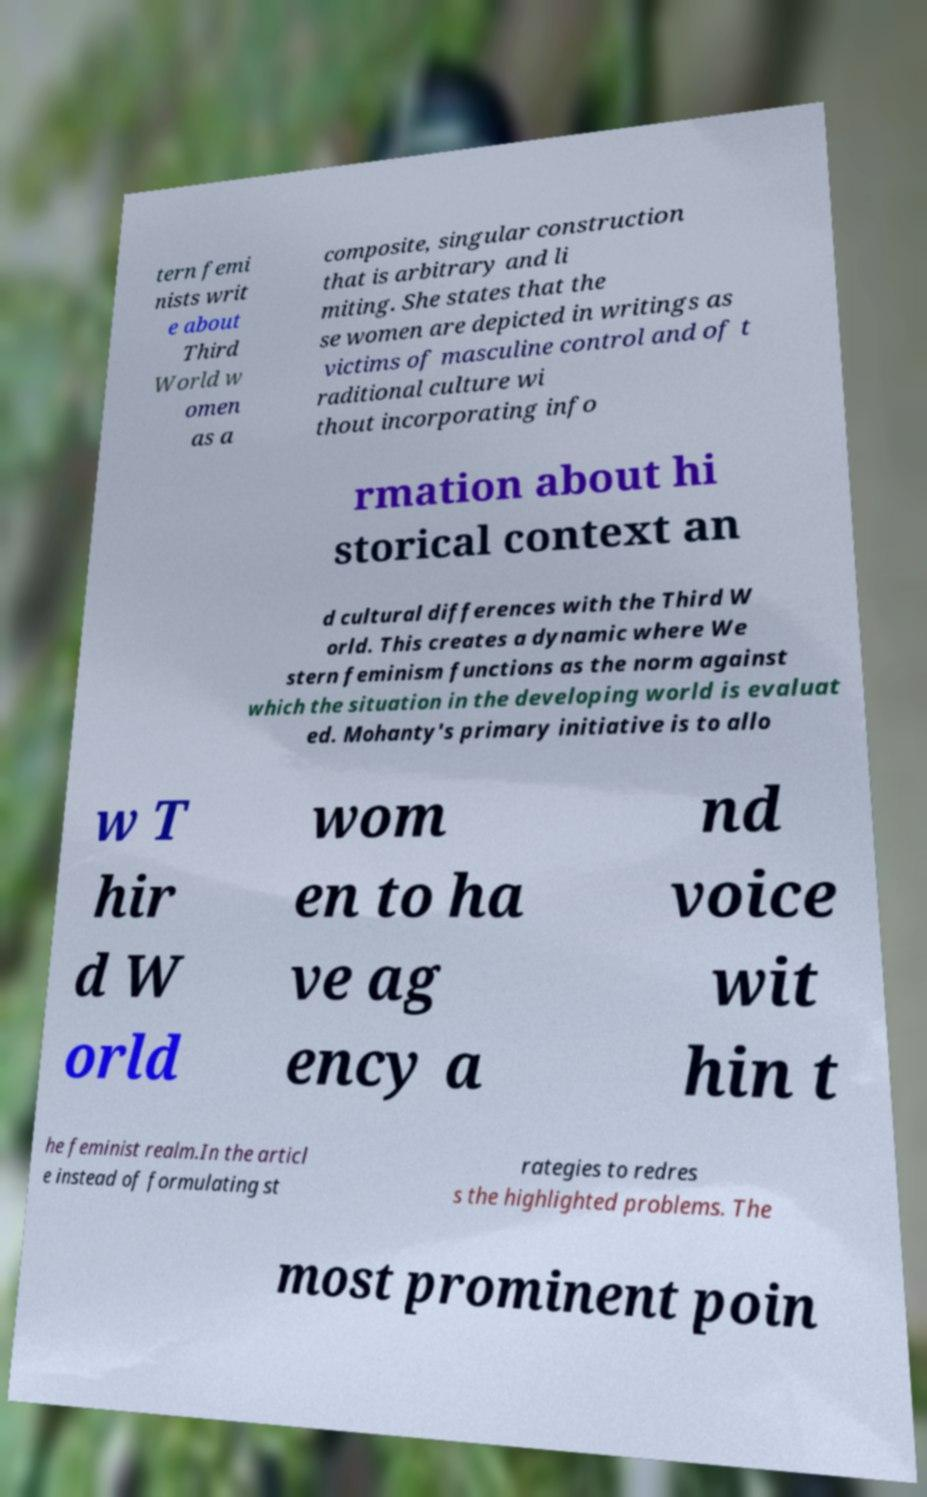For documentation purposes, I need the text within this image transcribed. Could you provide that? tern femi nists writ e about Third World w omen as a composite, singular construction that is arbitrary and li miting. She states that the se women are depicted in writings as victims of masculine control and of t raditional culture wi thout incorporating info rmation about hi storical context an d cultural differences with the Third W orld. This creates a dynamic where We stern feminism functions as the norm against which the situation in the developing world is evaluat ed. Mohanty's primary initiative is to allo w T hir d W orld wom en to ha ve ag ency a nd voice wit hin t he feminist realm.In the articl e instead of formulating st rategies to redres s the highlighted problems. The most prominent poin 